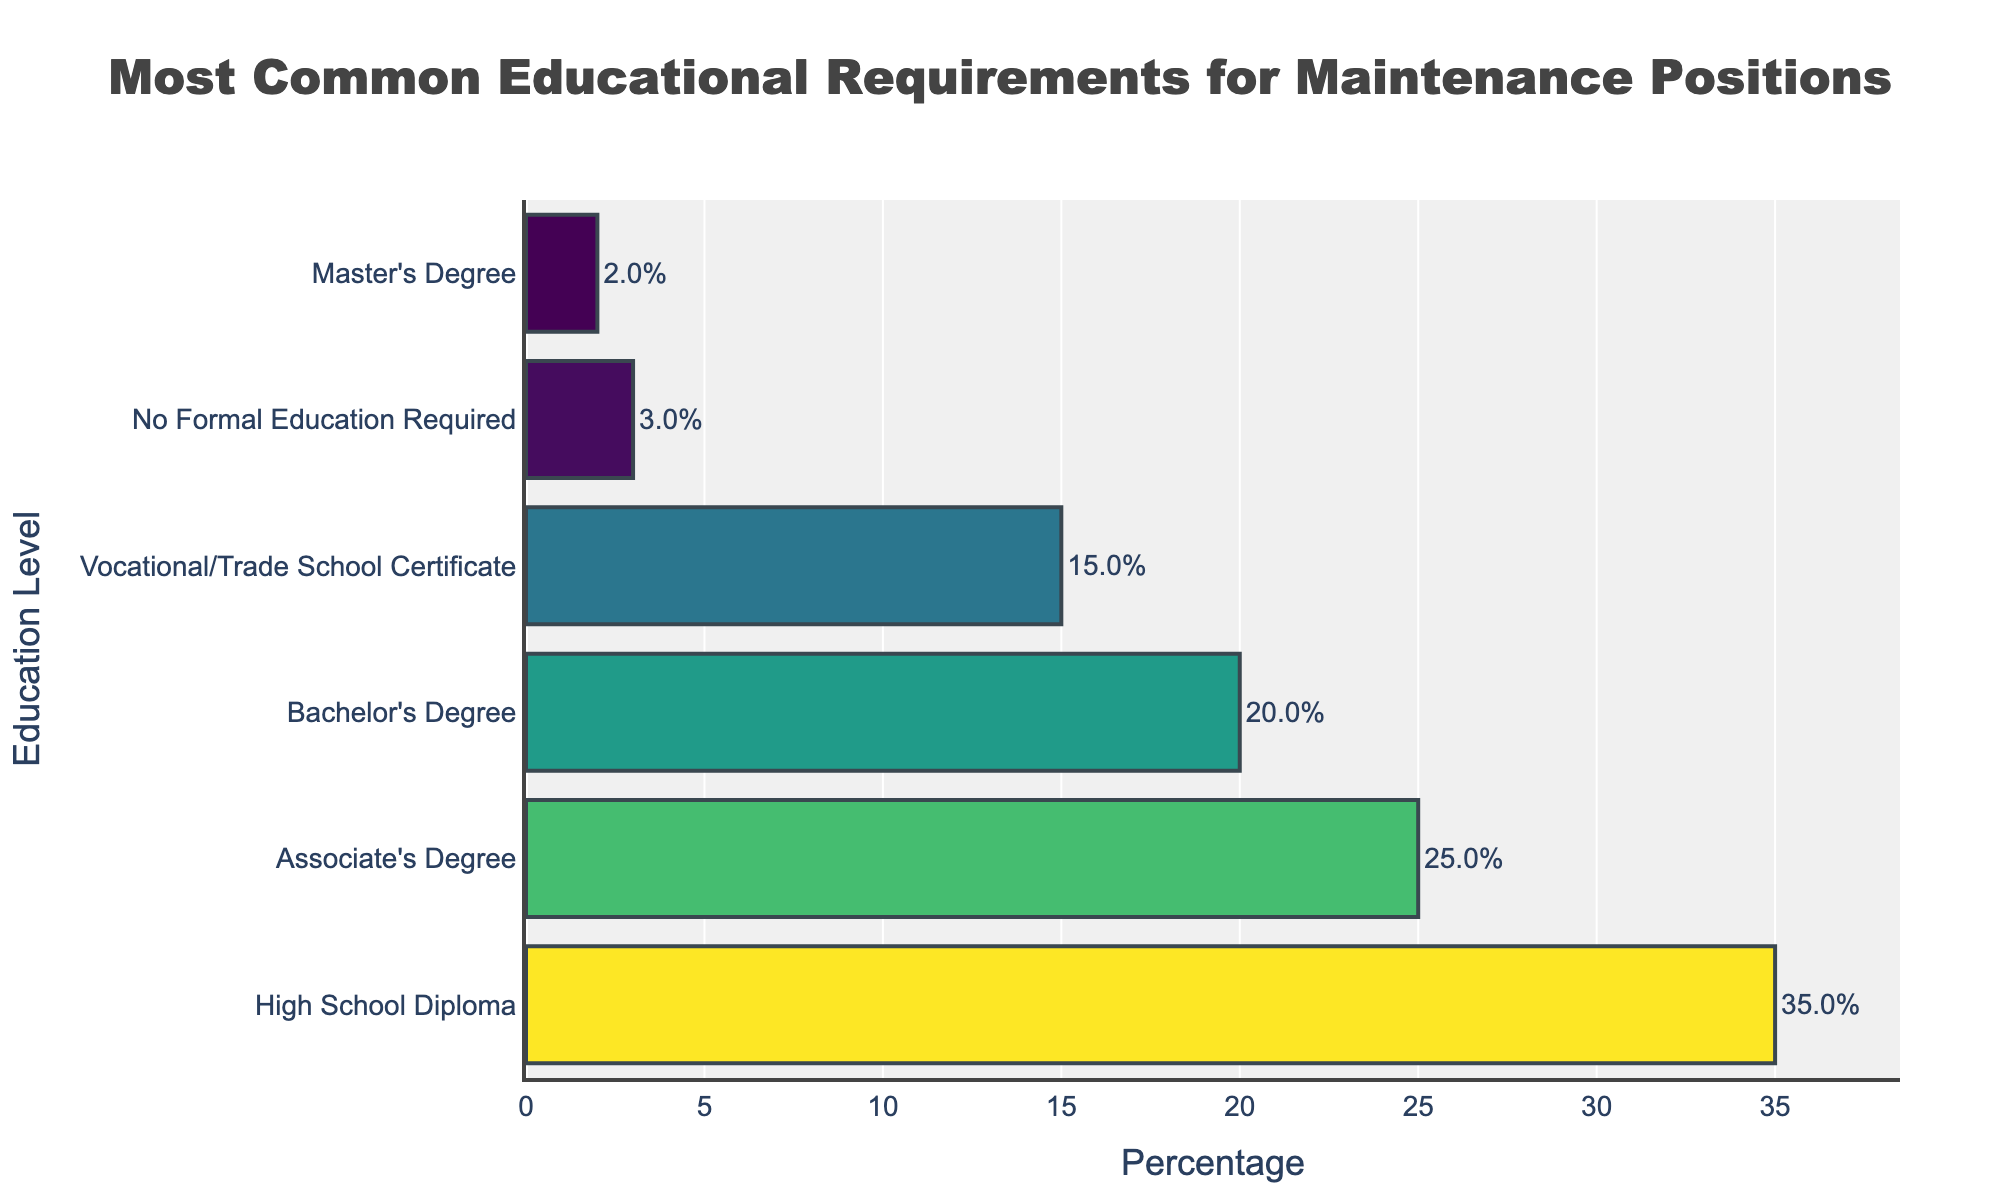what is the most common educational requirement for maintenance positions? The bar representing "High School Diploma" is the longest, indicating it has the highest percentage.
Answer: High School Diploma which educational level has the smallest percentage of requirements? The bar representing "Master's Degree" is the shortest, indicating it has the smallest percentage.
Answer: Master's Degree what is the total percentage of job requirements that ask for any form of post-secondary education (Associate's Degree and higher)? Sum the percentages of "Associate's Degree" (25%), "Bachelor's Degree" (20%), and "Master's Degree" (2%). 25% + 20% + 2% = 47%
Answer: 47% what is the difference in percentage between positions that require a Bachelor's Degree and those that require a Vocational/Trade School Certificate? Subtract the percentage of "Vocational/Trade School Certificate" (15%) from "Bachelor's Degree" (20%). 20% - 15% = 5%
Answer: 5% how do the education levels compare visually in the color scheme? "High School Diploma" has the darkest shade, and "Master's Degree" has the lightest shade, with the other levels having intermediate shades. The shades represent the percentage values where darker means higher.
Answer: Darker shades represent higher percentages how much more common is it for positions to require a High School Diploma compared to no formal education? Subtract the percentage of "No Formal Education Required" (3%) from "High School Diploma" (35%). 35% - 3% = 32%
Answer: 32% are there more positions requiring a Vocational/Trade School Certificate or an Associate's Degree? The length of the bar for "Associate's Degree" is longer than that for "Vocational/Trade School Certificate”.
Answer: Associate's Degree what is the combined percentage of positions requiring either a High School Diploma or a Bachelor's Degree? Sum the percentages of "High School Diploma" (35%) and "Bachelor's Degree" (20%). 35% + 20% = 55%
Answer: 55% which educational level has a percentage closest to 20%? The bar for "Bachelor's Degree" is exactly at 20%.
Answer: Bachelor's Degree what is the average percentage of all educational requirements listed? Sum all percentages and divide by the number of categories: (35% + 25% + 20% + 15% + 3% + 2%) / 6 = 100% / 6 ≈ 16.67%
Answer: 16.67% 